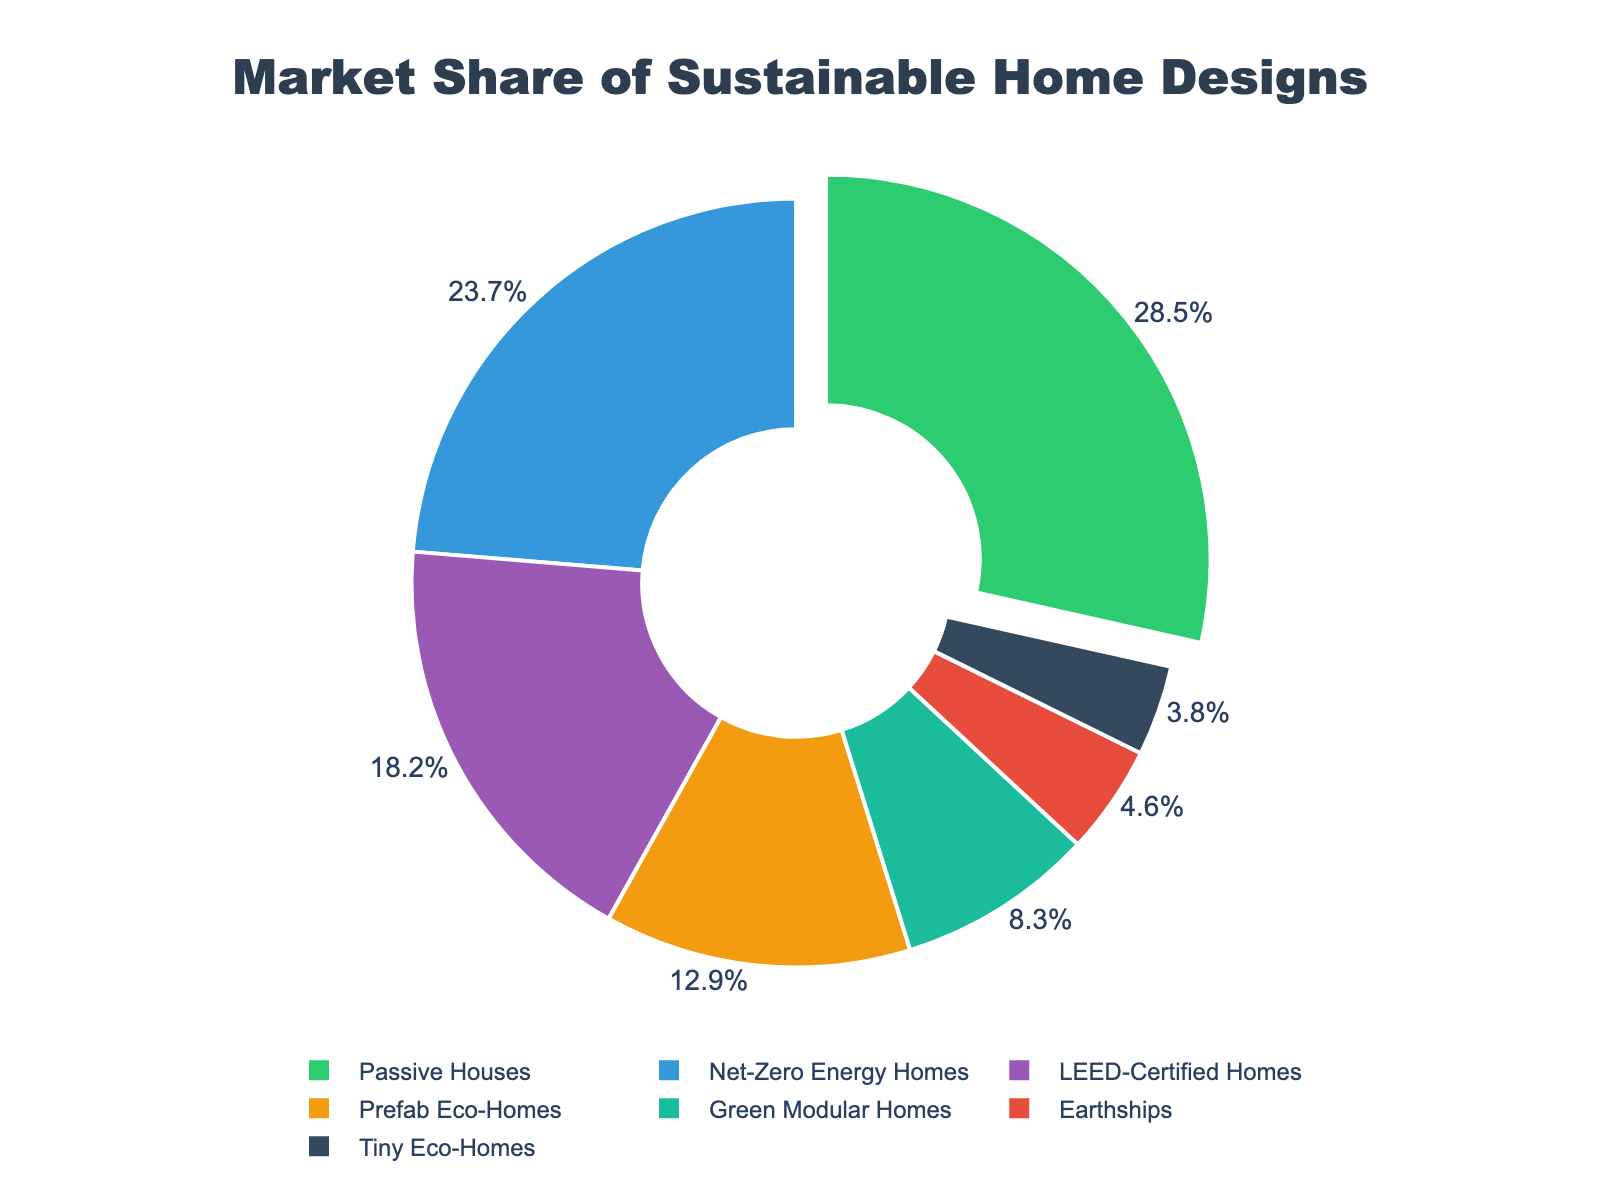What sustainable home design has the highest market share? To determine the home design with the highest market share, look at the chart and identify the segment with the largest percentage. The "Passive Houses" segment is the largest at 28.5%.
Answer: Passive Houses How much higher is the market share of Passive Houses compared to Tiny Eco-Homes? Locate the market share values for Passive Houses (28.5%) and Tiny Eco-Homes (3.8%). Subtract the Tiny Eco-Homes value from the Passive Houses value: 28.5% - 3.8% = 24.7%.
Answer: 24.7% What is the combined market share of LEED-Certified Homes and Net-Zero Energy Homes? Identify the market share for LEED-Certified Homes (18.2%) and Net-Zero Energy Homes (23.7%). Add these two values together to get the combined share: 18.2% + 23.7% = 41.9%.
Answer: 41.9% How does the market share of Green Modular Homes compare to that of Prefab Eco-Homes? Locate the market share values for Green Modular Homes (8.3%) and Prefab Eco-Homes (12.9%). 8.3% is less than 12.9%.
Answer: Less than Which home design has the smallest market share, and what is that share? Look for the segment with the smallest percentage. Tiny Eco-Homes has the smallest market share at 3.8%.
Answer: Tiny Eco-Homes, 3.8% What is the average market share of Earthships, Tiny Eco-Homes, and Green Modular Homes? Find the individual market shares: Earthships (4.6%), Tiny Eco-Homes (3.8%), and Green Modular Homes (8.3%). Add them together and then divide by the number of designs: (4.6 + 3.8 + 8.3) / 3 = 5.5667%.
Answer: 5.6% What is the total market share of all home designs that exceed 10%? Identify the segments with market shares greater than 10%: Passive Houses (28.5%), Net-Zero Energy Homes (23.7%), and Prefab Eco-Homes (12.9%). Add these values together: 28.5% + 23.7% + 12.9% = 65.1%.
Answer: 65.1% Which home design is just slightly larger in market share than Earthships? Locate the market share of Earthships (4.6%) and find the segment with the next highest share, which is Green Modular Homes at 8.3%.
Answer: Green Modular Homes What percentage of the market do Earthships and Tiny Eco-Homes hold together? Find the market shares for Earthships (4.6%) and Tiny Eco-Homes (3.8%). Add these values together: 4.6% + 3.8% = 8.4%.
Answer: 8.4% What is the relative difference in market share between the top and bottom segments? Identify the top segment (Passive Houses at 28.5%) and the bottom segment (Tiny Eco-Homes at 3.8%). Calculate the relative difference: (28.5% - 3.8%) / 3.8% = 6.5.
Answer: 6.5 